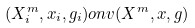<formula> <loc_0><loc_0><loc_500><loc_500>( X _ { i } ^ { m } , x _ { i } , g _ { i } ) o n v ( X ^ { m } , x , g )</formula> 